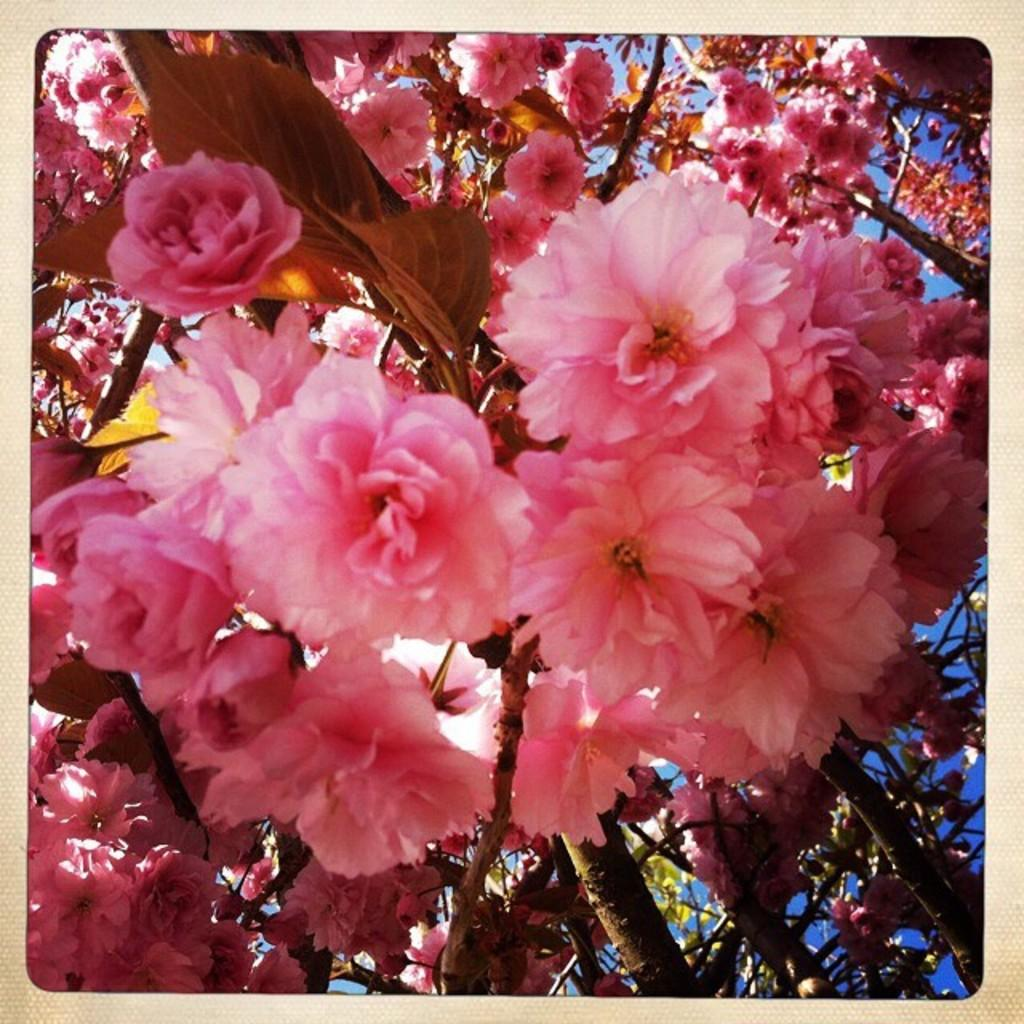What can be seen in the image that is related to plants? There are branches in the image. What features can be observed on the branches? The branches have flowers and leaves. What color are the flowers on the branches? The flowers are pink in color. What is visible in the background of the image? The sky is visible in the background of the image. Are there any letters written on the branches in the image? No, there are no letters written on the branches in the image. 